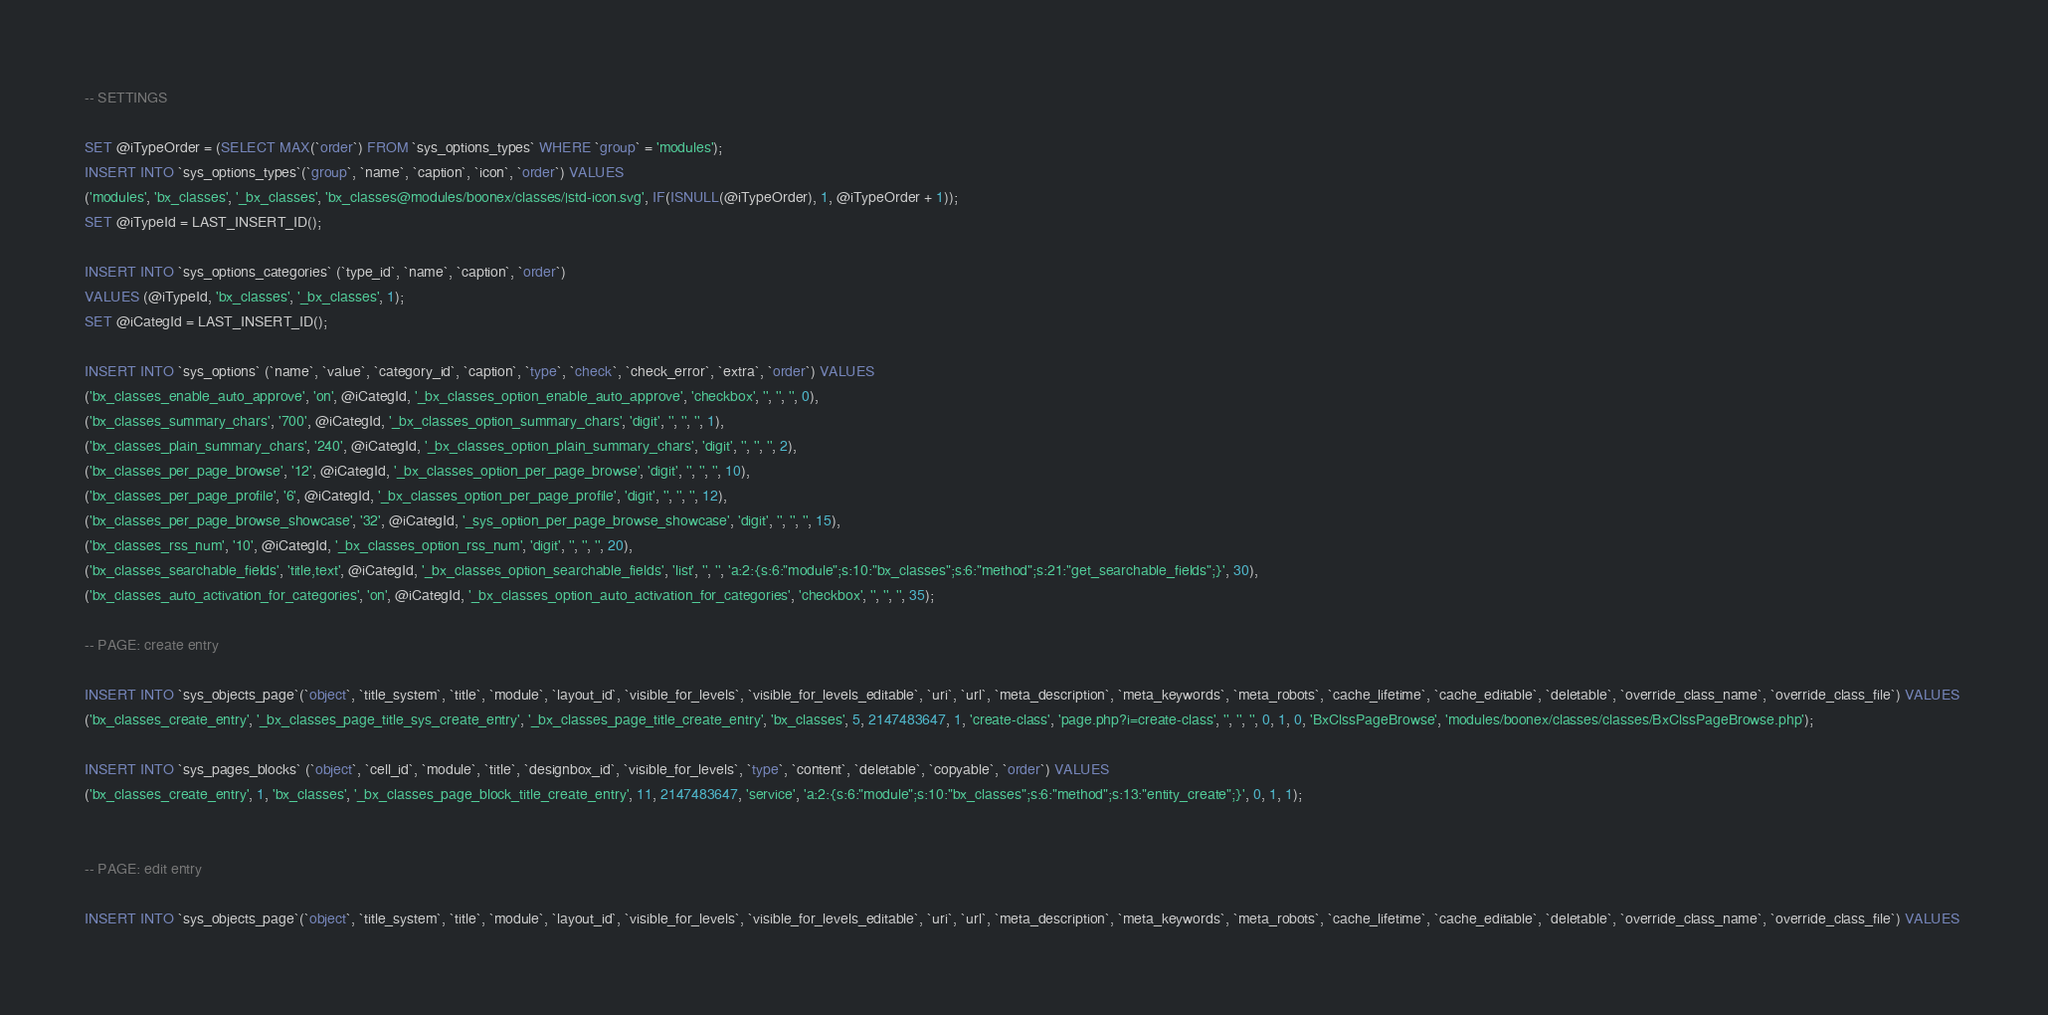Convert code to text. <code><loc_0><loc_0><loc_500><loc_500><_SQL_>
-- SETTINGS

SET @iTypeOrder = (SELECT MAX(`order`) FROM `sys_options_types` WHERE `group` = 'modules');
INSERT INTO `sys_options_types`(`group`, `name`, `caption`, `icon`, `order`) VALUES 
('modules', 'bx_classes', '_bx_classes', 'bx_classes@modules/boonex/classes/|std-icon.svg', IF(ISNULL(@iTypeOrder), 1, @iTypeOrder + 1));
SET @iTypeId = LAST_INSERT_ID();

INSERT INTO `sys_options_categories` (`type_id`, `name`, `caption`, `order`)
VALUES (@iTypeId, 'bx_classes', '_bx_classes', 1);
SET @iCategId = LAST_INSERT_ID();

INSERT INTO `sys_options` (`name`, `value`, `category_id`, `caption`, `type`, `check`, `check_error`, `extra`, `order`) VALUES
('bx_classes_enable_auto_approve', 'on', @iCategId, '_bx_classes_option_enable_auto_approve', 'checkbox', '', '', '', 0),
('bx_classes_summary_chars', '700', @iCategId, '_bx_classes_option_summary_chars', 'digit', '', '', '', 1),
('bx_classes_plain_summary_chars', '240', @iCategId, '_bx_classes_option_plain_summary_chars', 'digit', '', '', '', 2),
('bx_classes_per_page_browse', '12', @iCategId, '_bx_classes_option_per_page_browse', 'digit', '', '', '', 10),
('bx_classes_per_page_profile', '6', @iCategId, '_bx_classes_option_per_page_profile', 'digit', '', '', '', 12),
('bx_classes_per_page_browse_showcase', '32', @iCategId, '_sys_option_per_page_browse_showcase', 'digit', '', '', '', 15),
('bx_classes_rss_num', '10', @iCategId, '_bx_classes_option_rss_num', 'digit', '', '', '', 20),
('bx_classes_searchable_fields', 'title,text', @iCategId, '_bx_classes_option_searchable_fields', 'list', '', '', 'a:2:{s:6:"module";s:10:"bx_classes";s:6:"method";s:21:"get_searchable_fields";}', 30),
('bx_classes_auto_activation_for_categories', 'on', @iCategId, '_bx_classes_option_auto_activation_for_categories', 'checkbox', '', '', '', 35);

-- PAGE: create entry

INSERT INTO `sys_objects_page`(`object`, `title_system`, `title`, `module`, `layout_id`, `visible_for_levels`, `visible_for_levels_editable`, `uri`, `url`, `meta_description`, `meta_keywords`, `meta_robots`, `cache_lifetime`, `cache_editable`, `deletable`, `override_class_name`, `override_class_file`) VALUES 
('bx_classes_create_entry', '_bx_classes_page_title_sys_create_entry', '_bx_classes_page_title_create_entry', 'bx_classes', 5, 2147483647, 1, 'create-class', 'page.php?i=create-class', '', '', '', 0, 1, 0, 'BxClssPageBrowse', 'modules/boonex/classes/classes/BxClssPageBrowse.php');

INSERT INTO `sys_pages_blocks` (`object`, `cell_id`, `module`, `title`, `designbox_id`, `visible_for_levels`, `type`, `content`, `deletable`, `copyable`, `order`) VALUES
('bx_classes_create_entry', 1, 'bx_classes', '_bx_classes_page_block_title_create_entry', 11, 2147483647, 'service', 'a:2:{s:6:"module";s:10:"bx_classes";s:6:"method";s:13:"entity_create";}', 0, 1, 1);


-- PAGE: edit entry

INSERT INTO `sys_objects_page`(`object`, `title_system`, `title`, `module`, `layout_id`, `visible_for_levels`, `visible_for_levels_editable`, `uri`, `url`, `meta_description`, `meta_keywords`, `meta_robots`, `cache_lifetime`, `cache_editable`, `deletable`, `override_class_name`, `override_class_file`) VALUES </code> 